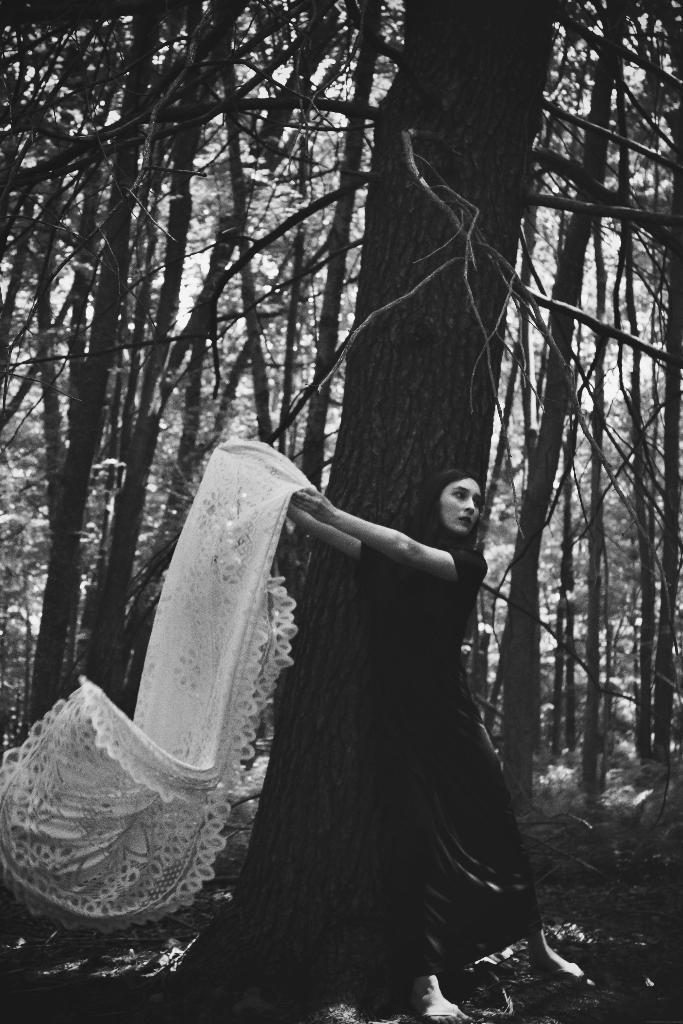Describe this image in one or two sentences. This picture is a black and white image. In this image we can see one woman standing and holding a white cloth near the tree. Some trees in the background, some dried stems and grass on the ground. 